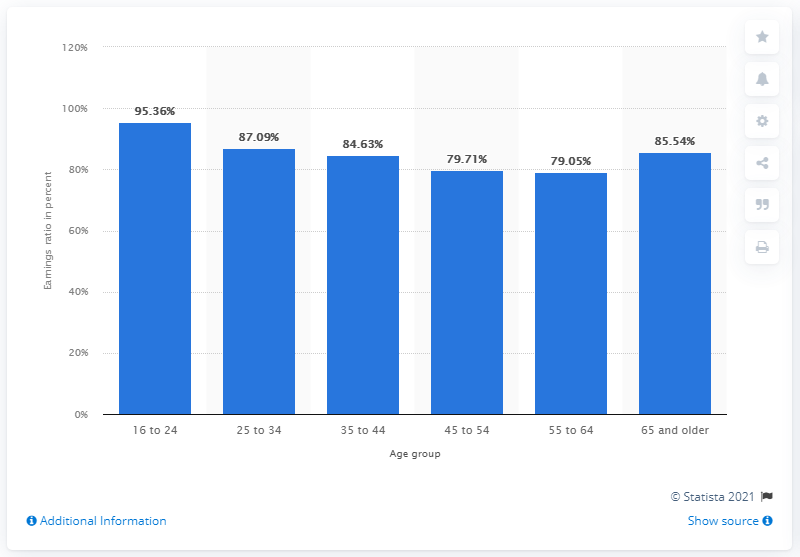Identify some key points in this picture. In the fourth quarter of 2020, the earnings ratio of female to male workers aged between 16 and 24 years was 95.36. 